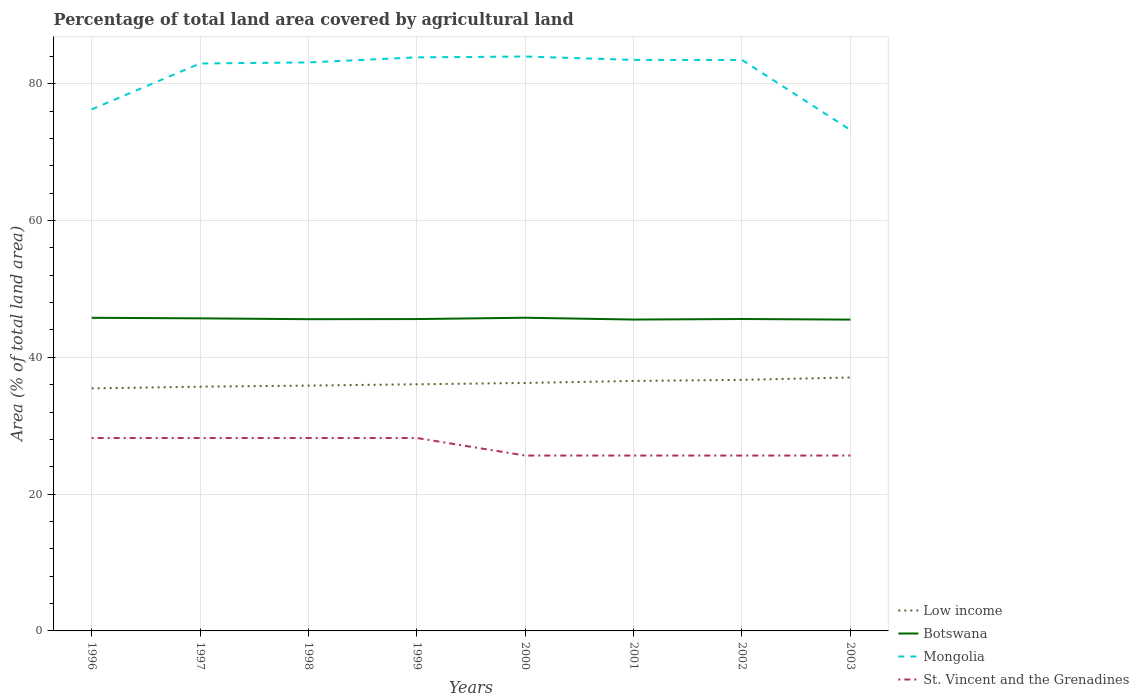How many different coloured lines are there?
Offer a terse response. 4. Does the line corresponding to St. Vincent and the Grenadines intersect with the line corresponding to Low income?
Offer a very short reply. No. Across all years, what is the maximum percentage of agricultural land in Botswana?
Your answer should be very brief. 45.52. In which year was the percentage of agricultural land in Botswana maximum?
Make the answer very short. 2003. What is the difference between the highest and the second highest percentage of agricultural land in Botswana?
Provide a short and direct response. 0.27. What is the difference between the highest and the lowest percentage of agricultural land in Botswana?
Your response must be concise. 3. How many lines are there?
Your response must be concise. 4. How many years are there in the graph?
Your answer should be very brief. 8. Where does the legend appear in the graph?
Your answer should be very brief. Bottom right. What is the title of the graph?
Provide a succinct answer. Percentage of total land area covered by agricultural land. What is the label or title of the X-axis?
Keep it short and to the point. Years. What is the label or title of the Y-axis?
Make the answer very short. Area (% of total land area). What is the Area (% of total land area) in Low income in 1996?
Provide a succinct answer. 35.46. What is the Area (% of total land area) of Botswana in 1996?
Offer a terse response. 45.78. What is the Area (% of total land area) of Mongolia in 1996?
Give a very brief answer. 76.26. What is the Area (% of total land area) in St. Vincent and the Grenadines in 1996?
Offer a terse response. 28.21. What is the Area (% of total land area) in Low income in 1997?
Keep it short and to the point. 35.71. What is the Area (% of total land area) in Botswana in 1997?
Keep it short and to the point. 45.7. What is the Area (% of total land area) of Mongolia in 1997?
Make the answer very short. 82.96. What is the Area (% of total land area) of St. Vincent and the Grenadines in 1997?
Offer a very short reply. 28.21. What is the Area (% of total land area) of Low income in 1998?
Offer a very short reply. 35.87. What is the Area (% of total land area) of Botswana in 1998?
Offer a terse response. 45.58. What is the Area (% of total land area) in Mongolia in 1998?
Make the answer very short. 83.12. What is the Area (% of total land area) in St. Vincent and the Grenadines in 1998?
Ensure brevity in your answer.  28.21. What is the Area (% of total land area) of Low income in 1999?
Your response must be concise. 36.06. What is the Area (% of total land area) of Botswana in 1999?
Offer a very short reply. 45.6. What is the Area (% of total land area) in Mongolia in 1999?
Your answer should be compact. 83.86. What is the Area (% of total land area) in St. Vincent and the Grenadines in 1999?
Your answer should be compact. 28.21. What is the Area (% of total land area) in Low income in 2000?
Make the answer very short. 36.25. What is the Area (% of total land area) of Botswana in 2000?
Keep it short and to the point. 45.79. What is the Area (% of total land area) in Mongolia in 2000?
Your answer should be compact. 83.98. What is the Area (% of total land area) in St. Vincent and the Grenadines in 2000?
Offer a terse response. 25.64. What is the Area (% of total land area) in Low income in 2001?
Ensure brevity in your answer.  36.55. What is the Area (% of total land area) in Botswana in 2001?
Your answer should be compact. 45.53. What is the Area (% of total land area) of Mongolia in 2001?
Give a very brief answer. 83.49. What is the Area (% of total land area) of St. Vincent and the Grenadines in 2001?
Offer a terse response. 25.64. What is the Area (% of total land area) in Low income in 2002?
Ensure brevity in your answer.  36.71. What is the Area (% of total land area) in Botswana in 2002?
Offer a terse response. 45.61. What is the Area (% of total land area) in Mongolia in 2002?
Make the answer very short. 83.48. What is the Area (% of total land area) of St. Vincent and the Grenadines in 2002?
Your answer should be very brief. 25.64. What is the Area (% of total land area) of Low income in 2003?
Ensure brevity in your answer.  37.05. What is the Area (% of total land area) in Botswana in 2003?
Keep it short and to the point. 45.52. What is the Area (% of total land area) in Mongolia in 2003?
Offer a very short reply. 73.25. What is the Area (% of total land area) of St. Vincent and the Grenadines in 2003?
Keep it short and to the point. 25.64. Across all years, what is the maximum Area (% of total land area) in Low income?
Provide a short and direct response. 37.05. Across all years, what is the maximum Area (% of total land area) in Botswana?
Offer a terse response. 45.79. Across all years, what is the maximum Area (% of total land area) in Mongolia?
Your response must be concise. 83.98. Across all years, what is the maximum Area (% of total land area) in St. Vincent and the Grenadines?
Give a very brief answer. 28.21. Across all years, what is the minimum Area (% of total land area) in Low income?
Your response must be concise. 35.46. Across all years, what is the minimum Area (% of total land area) of Botswana?
Make the answer very short. 45.52. Across all years, what is the minimum Area (% of total land area) in Mongolia?
Your answer should be very brief. 73.25. Across all years, what is the minimum Area (% of total land area) in St. Vincent and the Grenadines?
Offer a very short reply. 25.64. What is the total Area (% of total land area) of Low income in the graph?
Provide a succinct answer. 289.67. What is the total Area (% of total land area) in Botswana in the graph?
Your response must be concise. 365.1. What is the total Area (% of total land area) of Mongolia in the graph?
Ensure brevity in your answer.  650.4. What is the total Area (% of total land area) of St. Vincent and the Grenadines in the graph?
Offer a very short reply. 215.38. What is the difference between the Area (% of total land area) in Low income in 1996 and that in 1997?
Offer a very short reply. -0.25. What is the difference between the Area (% of total land area) of Botswana in 1996 and that in 1997?
Offer a very short reply. 0.08. What is the difference between the Area (% of total land area) in Mongolia in 1996 and that in 1997?
Ensure brevity in your answer.  -6.71. What is the difference between the Area (% of total land area) of St. Vincent and the Grenadines in 1996 and that in 1997?
Your answer should be very brief. 0. What is the difference between the Area (% of total land area) in Low income in 1996 and that in 1998?
Offer a very short reply. -0.41. What is the difference between the Area (% of total land area) in Botswana in 1996 and that in 1998?
Offer a terse response. 0.2. What is the difference between the Area (% of total land area) in Mongolia in 1996 and that in 1998?
Make the answer very short. -6.86. What is the difference between the Area (% of total land area) of Low income in 1996 and that in 1999?
Offer a terse response. -0.6. What is the difference between the Area (% of total land area) in Botswana in 1996 and that in 1999?
Offer a very short reply. 0.19. What is the difference between the Area (% of total land area) of Mongolia in 1996 and that in 1999?
Give a very brief answer. -7.6. What is the difference between the Area (% of total land area) of Low income in 1996 and that in 2000?
Your answer should be very brief. -0.79. What is the difference between the Area (% of total land area) of Botswana in 1996 and that in 2000?
Keep it short and to the point. -0.01. What is the difference between the Area (% of total land area) of Mongolia in 1996 and that in 2000?
Give a very brief answer. -7.72. What is the difference between the Area (% of total land area) in St. Vincent and the Grenadines in 1996 and that in 2000?
Offer a very short reply. 2.56. What is the difference between the Area (% of total land area) of Low income in 1996 and that in 2001?
Offer a very short reply. -1.09. What is the difference between the Area (% of total land area) in Botswana in 1996 and that in 2001?
Make the answer very short. 0.26. What is the difference between the Area (% of total land area) of Mongolia in 1996 and that in 2001?
Provide a succinct answer. -7.23. What is the difference between the Area (% of total land area) of St. Vincent and the Grenadines in 1996 and that in 2001?
Ensure brevity in your answer.  2.56. What is the difference between the Area (% of total land area) in Low income in 1996 and that in 2002?
Offer a terse response. -1.24. What is the difference between the Area (% of total land area) in Botswana in 1996 and that in 2002?
Your answer should be compact. 0.18. What is the difference between the Area (% of total land area) of Mongolia in 1996 and that in 2002?
Ensure brevity in your answer.  -7.23. What is the difference between the Area (% of total land area) of St. Vincent and the Grenadines in 1996 and that in 2002?
Your response must be concise. 2.56. What is the difference between the Area (% of total land area) of Low income in 1996 and that in 2003?
Keep it short and to the point. -1.59. What is the difference between the Area (% of total land area) in Botswana in 1996 and that in 2003?
Your answer should be compact. 0.26. What is the difference between the Area (% of total land area) of Mongolia in 1996 and that in 2003?
Your answer should be very brief. 3.01. What is the difference between the Area (% of total land area) in St. Vincent and the Grenadines in 1996 and that in 2003?
Your answer should be very brief. 2.56. What is the difference between the Area (% of total land area) of Low income in 1997 and that in 1998?
Give a very brief answer. -0.16. What is the difference between the Area (% of total land area) of Botswana in 1997 and that in 1998?
Provide a short and direct response. 0.12. What is the difference between the Area (% of total land area) of Mongolia in 1997 and that in 1998?
Offer a very short reply. -0.16. What is the difference between the Area (% of total land area) of Low income in 1997 and that in 1999?
Your response must be concise. -0.35. What is the difference between the Area (% of total land area) of Botswana in 1997 and that in 1999?
Your answer should be very brief. 0.11. What is the difference between the Area (% of total land area) in Mongolia in 1997 and that in 1999?
Offer a very short reply. -0.9. What is the difference between the Area (% of total land area) in Low income in 1997 and that in 2000?
Ensure brevity in your answer.  -0.54. What is the difference between the Area (% of total land area) of Botswana in 1997 and that in 2000?
Your answer should be compact. -0.09. What is the difference between the Area (% of total land area) of Mongolia in 1997 and that in 2000?
Provide a succinct answer. -1.02. What is the difference between the Area (% of total land area) in St. Vincent and the Grenadines in 1997 and that in 2000?
Your answer should be very brief. 2.56. What is the difference between the Area (% of total land area) of Low income in 1997 and that in 2001?
Provide a succinct answer. -0.84. What is the difference between the Area (% of total land area) in Botswana in 1997 and that in 2001?
Give a very brief answer. 0.18. What is the difference between the Area (% of total land area) in Mongolia in 1997 and that in 2001?
Your response must be concise. -0.52. What is the difference between the Area (% of total land area) of St. Vincent and the Grenadines in 1997 and that in 2001?
Your response must be concise. 2.56. What is the difference between the Area (% of total land area) of Low income in 1997 and that in 2002?
Your response must be concise. -0.99. What is the difference between the Area (% of total land area) in Botswana in 1997 and that in 2002?
Make the answer very short. 0.1. What is the difference between the Area (% of total land area) of Mongolia in 1997 and that in 2002?
Your response must be concise. -0.52. What is the difference between the Area (% of total land area) in St. Vincent and the Grenadines in 1997 and that in 2002?
Ensure brevity in your answer.  2.56. What is the difference between the Area (% of total land area) of Low income in 1997 and that in 2003?
Provide a succinct answer. -1.34. What is the difference between the Area (% of total land area) in Botswana in 1997 and that in 2003?
Give a very brief answer. 0.19. What is the difference between the Area (% of total land area) of Mongolia in 1997 and that in 2003?
Your answer should be very brief. 9.72. What is the difference between the Area (% of total land area) of St. Vincent and the Grenadines in 1997 and that in 2003?
Your response must be concise. 2.56. What is the difference between the Area (% of total land area) in Low income in 1998 and that in 1999?
Your answer should be compact. -0.19. What is the difference between the Area (% of total land area) in Botswana in 1998 and that in 1999?
Your answer should be very brief. -0.02. What is the difference between the Area (% of total land area) of Mongolia in 1998 and that in 1999?
Offer a terse response. -0.74. What is the difference between the Area (% of total land area) in Low income in 1998 and that in 2000?
Give a very brief answer. -0.39. What is the difference between the Area (% of total land area) of Botswana in 1998 and that in 2000?
Provide a short and direct response. -0.21. What is the difference between the Area (% of total land area) of Mongolia in 1998 and that in 2000?
Provide a short and direct response. -0.86. What is the difference between the Area (% of total land area) in St. Vincent and the Grenadines in 1998 and that in 2000?
Your answer should be compact. 2.56. What is the difference between the Area (% of total land area) of Low income in 1998 and that in 2001?
Keep it short and to the point. -0.68. What is the difference between the Area (% of total land area) of Botswana in 1998 and that in 2001?
Your response must be concise. 0.05. What is the difference between the Area (% of total land area) of Mongolia in 1998 and that in 2001?
Make the answer very short. -0.37. What is the difference between the Area (% of total land area) of St. Vincent and the Grenadines in 1998 and that in 2001?
Your response must be concise. 2.56. What is the difference between the Area (% of total land area) in Low income in 1998 and that in 2002?
Provide a succinct answer. -0.84. What is the difference between the Area (% of total land area) in Botswana in 1998 and that in 2002?
Make the answer very short. -0.03. What is the difference between the Area (% of total land area) of Mongolia in 1998 and that in 2002?
Give a very brief answer. -0.36. What is the difference between the Area (% of total land area) in St. Vincent and the Grenadines in 1998 and that in 2002?
Offer a very short reply. 2.56. What is the difference between the Area (% of total land area) of Low income in 1998 and that in 2003?
Offer a terse response. -1.19. What is the difference between the Area (% of total land area) in Botswana in 1998 and that in 2003?
Give a very brief answer. 0.06. What is the difference between the Area (% of total land area) of Mongolia in 1998 and that in 2003?
Keep it short and to the point. 9.87. What is the difference between the Area (% of total land area) of St. Vincent and the Grenadines in 1998 and that in 2003?
Your answer should be very brief. 2.56. What is the difference between the Area (% of total land area) of Low income in 1999 and that in 2000?
Your response must be concise. -0.19. What is the difference between the Area (% of total land area) of Botswana in 1999 and that in 2000?
Provide a short and direct response. -0.19. What is the difference between the Area (% of total land area) in Mongolia in 1999 and that in 2000?
Provide a succinct answer. -0.12. What is the difference between the Area (% of total land area) of St. Vincent and the Grenadines in 1999 and that in 2000?
Offer a very short reply. 2.56. What is the difference between the Area (% of total land area) of Low income in 1999 and that in 2001?
Your answer should be compact. -0.49. What is the difference between the Area (% of total land area) in Botswana in 1999 and that in 2001?
Your answer should be compact. 0.07. What is the difference between the Area (% of total land area) in Mongolia in 1999 and that in 2001?
Your answer should be compact. 0.37. What is the difference between the Area (% of total land area) in St. Vincent and the Grenadines in 1999 and that in 2001?
Offer a very short reply. 2.56. What is the difference between the Area (% of total land area) of Low income in 1999 and that in 2002?
Your answer should be very brief. -0.65. What is the difference between the Area (% of total land area) in Botswana in 1999 and that in 2002?
Provide a succinct answer. -0.01. What is the difference between the Area (% of total land area) in Mongolia in 1999 and that in 2002?
Provide a succinct answer. 0.38. What is the difference between the Area (% of total land area) of St. Vincent and the Grenadines in 1999 and that in 2002?
Provide a succinct answer. 2.56. What is the difference between the Area (% of total land area) of Low income in 1999 and that in 2003?
Make the answer very short. -0.99. What is the difference between the Area (% of total land area) in Botswana in 1999 and that in 2003?
Make the answer very short. 0.08. What is the difference between the Area (% of total land area) in Mongolia in 1999 and that in 2003?
Your response must be concise. 10.61. What is the difference between the Area (% of total land area) of St. Vincent and the Grenadines in 1999 and that in 2003?
Your answer should be very brief. 2.56. What is the difference between the Area (% of total land area) in Low income in 2000 and that in 2001?
Ensure brevity in your answer.  -0.29. What is the difference between the Area (% of total land area) in Botswana in 2000 and that in 2001?
Your response must be concise. 0.26. What is the difference between the Area (% of total land area) of Mongolia in 2000 and that in 2001?
Offer a terse response. 0.49. What is the difference between the Area (% of total land area) of Low income in 2000 and that in 2002?
Offer a terse response. -0.45. What is the difference between the Area (% of total land area) in Botswana in 2000 and that in 2002?
Your answer should be very brief. 0.19. What is the difference between the Area (% of total land area) in Mongolia in 2000 and that in 2002?
Provide a short and direct response. 0.5. What is the difference between the Area (% of total land area) of St. Vincent and the Grenadines in 2000 and that in 2002?
Provide a succinct answer. 0. What is the difference between the Area (% of total land area) of Low income in 2000 and that in 2003?
Make the answer very short. -0.8. What is the difference between the Area (% of total land area) of Botswana in 2000 and that in 2003?
Offer a terse response. 0.27. What is the difference between the Area (% of total land area) in Mongolia in 2000 and that in 2003?
Your answer should be very brief. 10.73. What is the difference between the Area (% of total land area) in Low income in 2001 and that in 2002?
Give a very brief answer. -0.16. What is the difference between the Area (% of total land area) in Botswana in 2001 and that in 2002?
Make the answer very short. -0.08. What is the difference between the Area (% of total land area) in Mongolia in 2001 and that in 2002?
Keep it short and to the point. 0.01. What is the difference between the Area (% of total land area) of Low income in 2001 and that in 2003?
Keep it short and to the point. -0.51. What is the difference between the Area (% of total land area) of Botswana in 2001 and that in 2003?
Give a very brief answer. 0.01. What is the difference between the Area (% of total land area) in Mongolia in 2001 and that in 2003?
Keep it short and to the point. 10.24. What is the difference between the Area (% of total land area) of St. Vincent and the Grenadines in 2001 and that in 2003?
Keep it short and to the point. 0. What is the difference between the Area (% of total land area) in Low income in 2002 and that in 2003?
Ensure brevity in your answer.  -0.35. What is the difference between the Area (% of total land area) in Botswana in 2002 and that in 2003?
Provide a short and direct response. 0.09. What is the difference between the Area (% of total land area) of Mongolia in 2002 and that in 2003?
Your response must be concise. 10.23. What is the difference between the Area (% of total land area) in St. Vincent and the Grenadines in 2002 and that in 2003?
Make the answer very short. 0. What is the difference between the Area (% of total land area) in Low income in 1996 and the Area (% of total land area) in Botswana in 1997?
Keep it short and to the point. -10.24. What is the difference between the Area (% of total land area) in Low income in 1996 and the Area (% of total land area) in Mongolia in 1997?
Provide a succinct answer. -47.5. What is the difference between the Area (% of total land area) in Low income in 1996 and the Area (% of total land area) in St. Vincent and the Grenadines in 1997?
Make the answer very short. 7.26. What is the difference between the Area (% of total land area) in Botswana in 1996 and the Area (% of total land area) in Mongolia in 1997?
Give a very brief answer. -37.18. What is the difference between the Area (% of total land area) in Botswana in 1996 and the Area (% of total land area) in St. Vincent and the Grenadines in 1997?
Provide a succinct answer. 17.58. What is the difference between the Area (% of total land area) in Mongolia in 1996 and the Area (% of total land area) in St. Vincent and the Grenadines in 1997?
Provide a succinct answer. 48.05. What is the difference between the Area (% of total land area) in Low income in 1996 and the Area (% of total land area) in Botswana in 1998?
Keep it short and to the point. -10.12. What is the difference between the Area (% of total land area) of Low income in 1996 and the Area (% of total land area) of Mongolia in 1998?
Offer a very short reply. -47.66. What is the difference between the Area (% of total land area) in Low income in 1996 and the Area (% of total land area) in St. Vincent and the Grenadines in 1998?
Your answer should be compact. 7.26. What is the difference between the Area (% of total land area) in Botswana in 1996 and the Area (% of total land area) in Mongolia in 1998?
Your response must be concise. -37.34. What is the difference between the Area (% of total land area) in Botswana in 1996 and the Area (% of total land area) in St. Vincent and the Grenadines in 1998?
Offer a very short reply. 17.58. What is the difference between the Area (% of total land area) in Mongolia in 1996 and the Area (% of total land area) in St. Vincent and the Grenadines in 1998?
Offer a very short reply. 48.05. What is the difference between the Area (% of total land area) of Low income in 1996 and the Area (% of total land area) of Botswana in 1999?
Your answer should be compact. -10.13. What is the difference between the Area (% of total land area) in Low income in 1996 and the Area (% of total land area) in Mongolia in 1999?
Make the answer very short. -48.4. What is the difference between the Area (% of total land area) in Low income in 1996 and the Area (% of total land area) in St. Vincent and the Grenadines in 1999?
Provide a succinct answer. 7.26. What is the difference between the Area (% of total land area) of Botswana in 1996 and the Area (% of total land area) of Mongolia in 1999?
Offer a very short reply. -38.08. What is the difference between the Area (% of total land area) of Botswana in 1996 and the Area (% of total land area) of St. Vincent and the Grenadines in 1999?
Your response must be concise. 17.58. What is the difference between the Area (% of total land area) in Mongolia in 1996 and the Area (% of total land area) in St. Vincent and the Grenadines in 1999?
Your response must be concise. 48.05. What is the difference between the Area (% of total land area) in Low income in 1996 and the Area (% of total land area) in Botswana in 2000?
Provide a succinct answer. -10.33. What is the difference between the Area (% of total land area) in Low income in 1996 and the Area (% of total land area) in Mongolia in 2000?
Provide a short and direct response. -48.52. What is the difference between the Area (% of total land area) in Low income in 1996 and the Area (% of total land area) in St. Vincent and the Grenadines in 2000?
Offer a very short reply. 9.82. What is the difference between the Area (% of total land area) in Botswana in 1996 and the Area (% of total land area) in Mongolia in 2000?
Make the answer very short. -38.2. What is the difference between the Area (% of total land area) of Botswana in 1996 and the Area (% of total land area) of St. Vincent and the Grenadines in 2000?
Your answer should be compact. 20.14. What is the difference between the Area (% of total land area) of Mongolia in 1996 and the Area (% of total land area) of St. Vincent and the Grenadines in 2000?
Your response must be concise. 50.62. What is the difference between the Area (% of total land area) of Low income in 1996 and the Area (% of total land area) of Botswana in 2001?
Give a very brief answer. -10.06. What is the difference between the Area (% of total land area) of Low income in 1996 and the Area (% of total land area) of Mongolia in 2001?
Offer a very short reply. -48.03. What is the difference between the Area (% of total land area) in Low income in 1996 and the Area (% of total land area) in St. Vincent and the Grenadines in 2001?
Give a very brief answer. 9.82. What is the difference between the Area (% of total land area) of Botswana in 1996 and the Area (% of total land area) of Mongolia in 2001?
Provide a short and direct response. -37.71. What is the difference between the Area (% of total land area) in Botswana in 1996 and the Area (% of total land area) in St. Vincent and the Grenadines in 2001?
Make the answer very short. 20.14. What is the difference between the Area (% of total land area) of Mongolia in 1996 and the Area (% of total land area) of St. Vincent and the Grenadines in 2001?
Provide a short and direct response. 50.62. What is the difference between the Area (% of total land area) of Low income in 1996 and the Area (% of total land area) of Botswana in 2002?
Ensure brevity in your answer.  -10.14. What is the difference between the Area (% of total land area) of Low income in 1996 and the Area (% of total land area) of Mongolia in 2002?
Ensure brevity in your answer.  -48.02. What is the difference between the Area (% of total land area) of Low income in 1996 and the Area (% of total land area) of St. Vincent and the Grenadines in 2002?
Provide a short and direct response. 9.82. What is the difference between the Area (% of total land area) in Botswana in 1996 and the Area (% of total land area) in Mongolia in 2002?
Give a very brief answer. -37.7. What is the difference between the Area (% of total land area) in Botswana in 1996 and the Area (% of total land area) in St. Vincent and the Grenadines in 2002?
Ensure brevity in your answer.  20.14. What is the difference between the Area (% of total land area) in Mongolia in 1996 and the Area (% of total land area) in St. Vincent and the Grenadines in 2002?
Offer a very short reply. 50.62. What is the difference between the Area (% of total land area) in Low income in 1996 and the Area (% of total land area) in Botswana in 2003?
Give a very brief answer. -10.06. What is the difference between the Area (% of total land area) in Low income in 1996 and the Area (% of total land area) in Mongolia in 2003?
Your response must be concise. -37.79. What is the difference between the Area (% of total land area) of Low income in 1996 and the Area (% of total land area) of St. Vincent and the Grenadines in 2003?
Make the answer very short. 9.82. What is the difference between the Area (% of total land area) of Botswana in 1996 and the Area (% of total land area) of Mongolia in 2003?
Your answer should be very brief. -27.47. What is the difference between the Area (% of total land area) of Botswana in 1996 and the Area (% of total land area) of St. Vincent and the Grenadines in 2003?
Your response must be concise. 20.14. What is the difference between the Area (% of total land area) of Mongolia in 1996 and the Area (% of total land area) of St. Vincent and the Grenadines in 2003?
Your response must be concise. 50.62. What is the difference between the Area (% of total land area) of Low income in 1997 and the Area (% of total land area) of Botswana in 1998?
Provide a succinct answer. -9.87. What is the difference between the Area (% of total land area) of Low income in 1997 and the Area (% of total land area) of Mongolia in 1998?
Your answer should be compact. -47.41. What is the difference between the Area (% of total land area) in Low income in 1997 and the Area (% of total land area) in St. Vincent and the Grenadines in 1998?
Offer a terse response. 7.51. What is the difference between the Area (% of total land area) in Botswana in 1997 and the Area (% of total land area) in Mongolia in 1998?
Ensure brevity in your answer.  -37.42. What is the difference between the Area (% of total land area) in Botswana in 1997 and the Area (% of total land area) in St. Vincent and the Grenadines in 1998?
Ensure brevity in your answer.  17.5. What is the difference between the Area (% of total land area) in Mongolia in 1997 and the Area (% of total land area) in St. Vincent and the Grenadines in 1998?
Provide a short and direct response. 54.76. What is the difference between the Area (% of total land area) of Low income in 1997 and the Area (% of total land area) of Botswana in 1999?
Provide a succinct answer. -9.89. What is the difference between the Area (% of total land area) of Low income in 1997 and the Area (% of total land area) of Mongolia in 1999?
Offer a very short reply. -48.15. What is the difference between the Area (% of total land area) of Low income in 1997 and the Area (% of total land area) of St. Vincent and the Grenadines in 1999?
Offer a very short reply. 7.51. What is the difference between the Area (% of total land area) in Botswana in 1997 and the Area (% of total land area) in Mongolia in 1999?
Your response must be concise. -38.16. What is the difference between the Area (% of total land area) of Botswana in 1997 and the Area (% of total land area) of St. Vincent and the Grenadines in 1999?
Ensure brevity in your answer.  17.5. What is the difference between the Area (% of total land area) in Mongolia in 1997 and the Area (% of total land area) in St. Vincent and the Grenadines in 1999?
Your answer should be very brief. 54.76. What is the difference between the Area (% of total land area) of Low income in 1997 and the Area (% of total land area) of Botswana in 2000?
Your response must be concise. -10.08. What is the difference between the Area (% of total land area) of Low income in 1997 and the Area (% of total land area) of Mongolia in 2000?
Your answer should be compact. -48.27. What is the difference between the Area (% of total land area) in Low income in 1997 and the Area (% of total land area) in St. Vincent and the Grenadines in 2000?
Give a very brief answer. 10.07. What is the difference between the Area (% of total land area) in Botswana in 1997 and the Area (% of total land area) in Mongolia in 2000?
Offer a very short reply. -38.28. What is the difference between the Area (% of total land area) in Botswana in 1997 and the Area (% of total land area) in St. Vincent and the Grenadines in 2000?
Your answer should be very brief. 20.06. What is the difference between the Area (% of total land area) of Mongolia in 1997 and the Area (% of total land area) of St. Vincent and the Grenadines in 2000?
Your answer should be compact. 57.32. What is the difference between the Area (% of total land area) in Low income in 1997 and the Area (% of total land area) in Botswana in 2001?
Provide a short and direct response. -9.81. What is the difference between the Area (% of total land area) in Low income in 1997 and the Area (% of total land area) in Mongolia in 2001?
Your answer should be compact. -47.78. What is the difference between the Area (% of total land area) of Low income in 1997 and the Area (% of total land area) of St. Vincent and the Grenadines in 2001?
Your answer should be very brief. 10.07. What is the difference between the Area (% of total land area) of Botswana in 1997 and the Area (% of total land area) of Mongolia in 2001?
Make the answer very short. -37.79. What is the difference between the Area (% of total land area) of Botswana in 1997 and the Area (% of total land area) of St. Vincent and the Grenadines in 2001?
Make the answer very short. 20.06. What is the difference between the Area (% of total land area) in Mongolia in 1997 and the Area (% of total land area) in St. Vincent and the Grenadines in 2001?
Offer a terse response. 57.32. What is the difference between the Area (% of total land area) of Low income in 1997 and the Area (% of total land area) of Botswana in 2002?
Offer a terse response. -9.89. What is the difference between the Area (% of total land area) in Low income in 1997 and the Area (% of total land area) in Mongolia in 2002?
Your response must be concise. -47.77. What is the difference between the Area (% of total land area) in Low income in 1997 and the Area (% of total land area) in St. Vincent and the Grenadines in 2002?
Keep it short and to the point. 10.07. What is the difference between the Area (% of total land area) in Botswana in 1997 and the Area (% of total land area) in Mongolia in 2002?
Offer a very short reply. -37.78. What is the difference between the Area (% of total land area) in Botswana in 1997 and the Area (% of total land area) in St. Vincent and the Grenadines in 2002?
Make the answer very short. 20.06. What is the difference between the Area (% of total land area) of Mongolia in 1997 and the Area (% of total land area) of St. Vincent and the Grenadines in 2002?
Your response must be concise. 57.32. What is the difference between the Area (% of total land area) of Low income in 1997 and the Area (% of total land area) of Botswana in 2003?
Offer a terse response. -9.81. What is the difference between the Area (% of total land area) in Low income in 1997 and the Area (% of total land area) in Mongolia in 2003?
Your response must be concise. -37.54. What is the difference between the Area (% of total land area) of Low income in 1997 and the Area (% of total land area) of St. Vincent and the Grenadines in 2003?
Provide a succinct answer. 10.07. What is the difference between the Area (% of total land area) in Botswana in 1997 and the Area (% of total land area) in Mongolia in 2003?
Provide a short and direct response. -27.55. What is the difference between the Area (% of total land area) of Botswana in 1997 and the Area (% of total land area) of St. Vincent and the Grenadines in 2003?
Offer a terse response. 20.06. What is the difference between the Area (% of total land area) of Mongolia in 1997 and the Area (% of total land area) of St. Vincent and the Grenadines in 2003?
Make the answer very short. 57.32. What is the difference between the Area (% of total land area) of Low income in 1998 and the Area (% of total land area) of Botswana in 1999?
Your response must be concise. -9.73. What is the difference between the Area (% of total land area) of Low income in 1998 and the Area (% of total land area) of Mongolia in 1999?
Your response must be concise. -47.99. What is the difference between the Area (% of total land area) of Low income in 1998 and the Area (% of total land area) of St. Vincent and the Grenadines in 1999?
Keep it short and to the point. 7.66. What is the difference between the Area (% of total land area) of Botswana in 1998 and the Area (% of total land area) of Mongolia in 1999?
Your response must be concise. -38.28. What is the difference between the Area (% of total land area) in Botswana in 1998 and the Area (% of total land area) in St. Vincent and the Grenadines in 1999?
Your answer should be compact. 17.37. What is the difference between the Area (% of total land area) in Mongolia in 1998 and the Area (% of total land area) in St. Vincent and the Grenadines in 1999?
Provide a short and direct response. 54.91. What is the difference between the Area (% of total land area) in Low income in 1998 and the Area (% of total land area) in Botswana in 2000?
Provide a succinct answer. -9.92. What is the difference between the Area (% of total land area) in Low income in 1998 and the Area (% of total land area) in Mongolia in 2000?
Keep it short and to the point. -48.11. What is the difference between the Area (% of total land area) of Low income in 1998 and the Area (% of total land area) of St. Vincent and the Grenadines in 2000?
Your answer should be compact. 10.23. What is the difference between the Area (% of total land area) in Botswana in 1998 and the Area (% of total land area) in Mongolia in 2000?
Provide a short and direct response. -38.4. What is the difference between the Area (% of total land area) in Botswana in 1998 and the Area (% of total land area) in St. Vincent and the Grenadines in 2000?
Your response must be concise. 19.94. What is the difference between the Area (% of total land area) in Mongolia in 1998 and the Area (% of total land area) in St. Vincent and the Grenadines in 2000?
Keep it short and to the point. 57.48. What is the difference between the Area (% of total land area) of Low income in 1998 and the Area (% of total land area) of Botswana in 2001?
Make the answer very short. -9.66. What is the difference between the Area (% of total land area) of Low income in 1998 and the Area (% of total land area) of Mongolia in 2001?
Make the answer very short. -47.62. What is the difference between the Area (% of total land area) in Low income in 1998 and the Area (% of total land area) in St. Vincent and the Grenadines in 2001?
Provide a short and direct response. 10.23. What is the difference between the Area (% of total land area) of Botswana in 1998 and the Area (% of total land area) of Mongolia in 2001?
Give a very brief answer. -37.91. What is the difference between the Area (% of total land area) in Botswana in 1998 and the Area (% of total land area) in St. Vincent and the Grenadines in 2001?
Your answer should be compact. 19.94. What is the difference between the Area (% of total land area) in Mongolia in 1998 and the Area (% of total land area) in St. Vincent and the Grenadines in 2001?
Make the answer very short. 57.48. What is the difference between the Area (% of total land area) of Low income in 1998 and the Area (% of total land area) of Botswana in 2002?
Give a very brief answer. -9.74. What is the difference between the Area (% of total land area) in Low income in 1998 and the Area (% of total land area) in Mongolia in 2002?
Ensure brevity in your answer.  -47.61. What is the difference between the Area (% of total land area) of Low income in 1998 and the Area (% of total land area) of St. Vincent and the Grenadines in 2002?
Make the answer very short. 10.23. What is the difference between the Area (% of total land area) in Botswana in 1998 and the Area (% of total land area) in Mongolia in 2002?
Offer a very short reply. -37.9. What is the difference between the Area (% of total land area) in Botswana in 1998 and the Area (% of total land area) in St. Vincent and the Grenadines in 2002?
Provide a succinct answer. 19.94. What is the difference between the Area (% of total land area) in Mongolia in 1998 and the Area (% of total land area) in St. Vincent and the Grenadines in 2002?
Give a very brief answer. 57.48. What is the difference between the Area (% of total land area) in Low income in 1998 and the Area (% of total land area) in Botswana in 2003?
Keep it short and to the point. -9.65. What is the difference between the Area (% of total land area) of Low income in 1998 and the Area (% of total land area) of Mongolia in 2003?
Your answer should be very brief. -37.38. What is the difference between the Area (% of total land area) in Low income in 1998 and the Area (% of total land area) in St. Vincent and the Grenadines in 2003?
Keep it short and to the point. 10.23. What is the difference between the Area (% of total land area) of Botswana in 1998 and the Area (% of total land area) of Mongolia in 2003?
Offer a terse response. -27.67. What is the difference between the Area (% of total land area) in Botswana in 1998 and the Area (% of total land area) in St. Vincent and the Grenadines in 2003?
Ensure brevity in your answer.  19.94. What is the difference between the Area (% of total land area) in Mongolia in 1998 and the Area (% of total land area) in St. Vincent and the Grenadines in 2003?
Your response must be concise. 57.48. What is the difference between the Area (% of total land area) of Low income in 1999 and the Area (% of total land area) of Botswana in 2000?
Offer a terse response. -9.73. What is the difference between the Area (% of total land area) of Low income in 1999 and the Area (% of total land area) of Mongolia in 2000?
Your answer should be very brief. -47.92. What is the difference between the Area (% of total land area) of Low income in 1999 and the Area (% of total land area) of St. Vincent and the Grenadines in 2000?
Keep it short and to the point. 10.42. What is the difference between the Area (% of total land area) of Botswana in 1999 and the Area (% of total land area) of Mongolia in 2000?
Provide a succinct answer. -38.38. What is the difference between the Area (% of total land area) in Botswana in 1999 and the Area (% of total land area) in St. Vincent and the Grenadines in 2000?
Give a very brief answer. 19.96. What is the difference between the Area (% of total land area) of Mongolia in 1999 and the Area (% of total land area) of St. Vincent and the Grenadines in 2000?
Offer a very short reply. 58.22. What is the difference between the Area (% of total land area) of Low income in 1999 and the Area (% of total land area) of Botswana in 2001?
Keep it short and to the point. -9.47. What is the difference between the Area (% of total land area) of Low income in 1999 and the Area (% of total land area) of Mongolia in 2001?
Give a very brief answer. -47.43. What is the difference between the Area (% of total land area) of Low income in 1999 and the Area (% of total land area) of St. Vincent and the Grenadines in 2001?
Your response must be concise. 10.42. What is the difference between the Area (% of total land area) of Botswana in 1999 and the Area (% of total land area) of Mongolia in 2001?
Give a very brief answer. -37.89. What is the difference between the Area (% of total land area) in Botswana in 1999 and the Area (% of total land area) in St. Vincent and the Grenadines in 2001?
Give a very brief answer. 19.96. What is the difference between the Area (% of total land area) of Mongolia in 1999 and the Area (% of total land area) of St. Vincent and the Grenadines in 2001?
Your response must be concise. 58.22. What is the difference between the Area (% of total land area) in Low income in 1999 and the Area (% of total land area) in Botswana in 2002?
Offer a very short reply. -9.54. What is the difference between the Area (% of total land area) of Low income in 1999 and the Area (% of total land area) of Mongolia in 2002?
Offer a terse response. -47.42. What is the difference between the Area (% of total land area) in Low income in 1999 and the Area (% of total land area) in St. Vincent and the Grenadines in 2002?
Give a very brief answer. 10.42. What is the difference between the Area (% of total land area) in Botswana in 1999 and the Area (% of total land area) in Mongolia in 2002?
Make the answer very short. -37.89. What is the difference between the Area (% of total land area) in Botswana in 1999 and the Area (% of total land area) in St. Vincent and the Grenadines in 2002?
Ensure brevity in your answer.  19.96. What is the difference between the Area (% of total land area) in Mongolia in 1999 and the Area (% of total land area) in St. Vincent and the Grenadines in 2002?
Your response must be concise. 58.22. What is the difference between the Area (% of total land area) of Low income in 1999 and the Area (% of total land area) of Botswana in 2003?
Your answer should be very brief. -9.46. What is the difference between the Area (% of total land area) of Low income in 1999 and the Area (% of total land area) of Mongolia in 2003?
Provide a short and direct response. -37.19. What is the difference between the Area (% of total land area) in Low income in 1999 and the Area (% of total land area) in St. Vincent and the Grenadines in 2003?
Ensure brevity in your answer.  10.42. What is the difference between the Area (% of total land area) in Botswana in 1999 and the Area (% of total land area) in Mongolia in 2003?
Provide a succinct answer. -27.65. What is the difference between the Area (% of total land area) in Botswana in 1999 and the Area (% of total land area) in St. Vincent and the Grenadines in 2003?
Your answer should be very brief. 19.96. What is the difference between the Area (% of total land area) in Mongolia in 1999 and the Area (% of total land area) in St. Vincent and the Grenadines in 2003?
Provide a succinct answer. 58.22. What is the difference between the Area (% of total land area) of Low income in 2000 and the Area (% of total land area) of Botswana in 2001?
Make the answer very short. -9.27. What is the difference between the Area (% of total land area) of Low income in 2000 and the Area (% of total land area) of Mongolia in 2001?
Offer a very short reply. -47.23. What is the difference between the Area (% of total land area) of Low income in 2000 and the Area (% of total land area) of St. Vincent and the Grenadines in 2001?
Offer a terse response. 10.61. What is the difference between the Area (% of total land area) of Botswana in 2000 and the Area (% of total land area) of Mongolia in 2001?
Offer a terse response. -37.7. What is the difference between the Area (% of total land area) of Botswana in 2000 and the Area (% of total land area) of St. Vincent and the Grenadines in 2001?
Ensure brevity in your answer.  20.15. What is the difference between the Area (% of total land area) in Mongolia in 2000 and the Area (% of total land area) in St. Vincent and the Grenadines in 2001?
Offer a very short reply. 58.34. What is the difference between the Area (% of total land area) of Low income in 2000 and the Area (% of total land area) of Botswana in 2002?
Keep it short and to the point. -9.35. What is the difference between the Area (% of total land area) in Low income in 2000 and the Area (% of total land area) in Mongolia in 2002?
Keep it short and to the point. -47.23. What is the difference between the Area (% of total land area) in Low income in 2000 and the Area (% of total land area) in St. Vincent and the Grenadines in 2002?
Keep it short and to the point. 10.61. What is the difference between the Area (% of total land area) of Botswana in 2000 and the Area (% of total land area) of Mongolia in 2002?
Offer a very short reply. -37.69. What is the difference between the Area (% of total land area) of Botswana in 2000 and the Area (% of total land area) of St. Vincent and the Grenadines in 2002?
Make the answer very short. 20.15. What is the difference between the Area (% of total land area) of Mongolia in 2000 and the Area (% of total land area) of St. Vincent and the Grenadines in 2002?
Offer a terse response. 58.34. What is the difference between the Area (% of total land area) of Low income in 2000 and the Area (% of total land area) of Botswana in 2003?
Give a very brief answer. -9.26. What is the difference between the Area (% of total land area) of Low income in 2000 and the Area (% of total land area) of Mongolia in 2003?
Ensure brevity in your answer.  -36.99. What is the difference between the Area (% of total land area) in Low income in 2000 and the Area (% of total land area) in St. Vincent and the Grenadines in 2003?
Offer a very short reply. 10.61. What is the difference between the Area (% of total land area) in Botswana in 2000 and the Area (% of total land area) in Mongolia in 2003?
Offer a terse response. -27.46. What is the difference between the Area (% of total land area) in Botswana in 2000 and the Area (% of total land area) in St. Vincent and the Grenadines in 2003?
Your answer should be very brief. 20.15. What is the difference between the Area (% of total land area) of Mongolia in 2000 and the Area (% of total land area) of St. Vincent and the Grenadines in 2003?
Keep it short and to the point. 58.34. What is the difference between the Area (% of total land area) of Low income in 2001 and the Area (% of total land area) of Botswana in 2002?
Provide a succinct answer. -9.06. What is the difference between the Area (% of total land area) of Low income in 2001 and the Area (% of total land area) of Mongolia in 2002?
Ensure brevity in your answer.  -46.93. What is the difference between the Area (% of total land area) in Low income in 2001 and the Area (% of total land area) in St. Vincent and the Grenadines in 2002?
Provide a succinct answer. 10.91. What is the difference between the Area (% of total land area) in Botswana in 2001 and the Area (% of total land area) in Mongolia in 2002?
Offer a terse response. -37.96. What is the difference between the Area (% of total land area) of Botswana in 2001 and the Area (% of total land area) of St. Vincent and the Grenadines in 2002?
Offer a terse response. 19.89. What is the difference between the Area (% of total land area) of Mongolia in 2001 and the Area (% of total land area) of St. Vincent and the Grenadines in 2002?
Provide a succinct answer. 57.85. What is the difference between the Area (% of total land area) in Low income in 2001 and the Area (% of total land area) in Botswana in 2003?
Give a very brief answer. -8.97. What is the difference between the Area (% of total land area) of Low income in 2001 and the Area (% of total land area) of Mongolia in 2003?
Ensure brevity in your answer.  -36.7. What is the difference between the Area (% of total land area) in Low income in 2001 and the Area (% of total land area) in St. Vincent and the Grenadines in 2003?
Your answer should be very brief. 10.91. What is the difference between the Area (% of total land area) of Botswana in 2001 and the Area (% of total land area) of Mongolia in 2003?
Provide a succinct answer. -27.72. What is the difference between the Area (% of total land area) of Botswana in 2001 and the Area (% of total land area) of St. Vincent and the Grenadines in 2003?
Your answer should be compact. 19.89. What is the difference between the Area (% of total land area) in Mongolia in 2001 and the Area (% of total land area) in St. Vincent and the Grenadines in 2003?
Offer a terse response. 57.85. What is the difference between the Area (% of total land area) in Low income in 2002 and the Area (% of total land area) in Botswana in 2003?
Offer a very short reply. -8.81. What is the difference between the Area (% of total land area) of Low income in 2002 and the Area (% of total land area) of Mongolia in 2003?
Keep it short and to the point. -36.54. What is the difference between the Area (% of total land area) in Low income in 2002 and the Area (% of total land area) in St. Vincent and the Grenadines in 2003?
Give a very brief answer. 11.06. What is the difference between the Area (% of total land area) of Botswana in 2002 and the Area (% of total land area) of Mongolia in 2003?
Give a very brief answer. -27.64. What is the difference between the Area (% of total land area) in Botswana in 2002 and the Area (% of total land area) in St. Vincent and the Grenadines in 2003?
Your answer should be very brief. 19.96. What is the difference between the Area (% of total land area) of Mongolia in 2002 and the Area (% of total land area) of St. Vincent and the Grenadines in 2003?
Provide a short and direct response. 57.84. What is the average Area (% of total land area) in Low income per year?
Provide a short and direct response. 36.21. What is the average Area (% of total land area) in Botswana per year?
Offer a very short reply. 45.64. What is the average Area (% of total land area) of Mongolia per year?
Provide a succinct answer. 81.3. What is the average Area (% of total land area) in St. Vincent and the Grenadines per year?
Your answer should be very brief. 26.92. In the year 1996, what is the difference between the Area (% of total land area) in Low income and Area (% of total land area) in Botswana?
Ensure brevity in your answer.  -10.32. In the year 1996, what is the difference between the Area (% of total land area) in Low income and Area (% of total land area) in Mongolia?
Give a very brief answer. -40.79. In the year 1996, what is the difference between the Area (% of total land area) in Low income and Area (% of total land area) in St. Vincent and the Grenadines?
Provide a succinct answer. 7.26. In the year 1996, what is the difference between the Area (% of total land area) in Botswana and Area (% of total land area) in Mongolia?
Give a very brief answer. -30.47. In the year 1996, what is the difference between the Area (% of total land area) in Botswana and Area (% of total land area) in St. Vincent and the Grenadines?
Give a very brief answer. 17.58. In the year 1996, what is the difference between the Area (% of total land area) in Mongolia and Area (% of total land area) in St. Vincent and the Grenadines?
Give a very brief answer. 48.05. In the year 1997, what is the difference between the Area (% of total land area) in Low income and Area (% of total land area) in Botswana?
Offer a terse response. -9.99. In the year 1997, what is the difference between the Area (% of total land area) in Low income and Area (% of total land area) in Mongolia?
Make the answer very short. -47.25. In the year 1997, what is the difference between the Area (% of total land area) of Low income and Area (% of total land area) of St. Vincent and the Grenadines?
Your answer should be very brief. 7.51. In the year 1997, what is the difference between the Area (% of total land area) of Botswana and Area (% of total land area) of Mongolia?
Make the answer very short. -37.26. In the year 1997, what is the difference between the Area (% of total land area) in Botswana and Area (% of total land area) in St. Vincent and the Grenadines?
Ensure brevity in your answer.  17.5. In the year 1997, what is the difference between the Area (% of total land area) of Mongolia and Area (% of total land area) of St. Vincent and the Grenadines?
Keep it short and to the point. 54.76. In the year 1998, what is the difference between the Area (% of total land area) in Low income and Area (% of total land area) in Botswana?
Keep it short and to the point. -9.71. In the year 1998, what is the difference between the Area (% of total land area) of Low income and Area (% of total land area) of Mongolia?
Offer a terse response. -47.25. In the year 1998, what is the difference between the Area (% of total land area) in Low income and Area (% of total land area) in St. Vincent and the Grenadines?
Keep it short and to the point. 7.66. In the year 1998, what is the difference between the Area (% of total land area) of Botswana and Area (% of total land area) of Mongolia?
Make the answer very short. -37.54. In the year 1998, what is the difference between the Area (% of total land area) in Botswana and Area (% of total land area) in St. Vincent and the Grenadines?
Offer a very short reply. 17.37. In the year 1998, what is the difference between the Area (% of total land area) of Mongolia and Area (% of total land area) of St. Vincent and the Grenadines?
Ensure brevity in your answer.  54.91. In the year 1999, what is the difference between the Area (% of total land area) in Low income and Area (% of total land area) in Botswana?
Provide a succinct answer. -9.54. In the year 1999, what is the difference between the Area (% of total land area) of Low income and Area (% of total land area) of Mongolia?
Your response must be concise. -47.8. In the year 1999, what is the difference between the Area (% of total land area) in Low income and Area (% of total land area) in St. Vincent and the Grenadines?
Your answer should be very brief. 7.86. In the year 1999, what is the difference between the Area (% of total land area) of Botswana and Area (% of total land area) of Mongolia?
Your response must be concise. -38.26. In the year 1999, what is the difference between the Area (% of total land area) in Botswana and Area (% of total land area) in St. Vincent and the Grenadines?
Provide a short and direct response. 17.39. In the year 1999, what is the difference between the Area (% of total land area) of Mongolia and Area (% of total land area) of St. Vincent and the Grenadines?
Your answer should be very brief. 55.66. In the year 2000, what is the difference between the Area (% of total land area) of Low income and Area (% of total land area) of Botswana?
Offer a very short reply. -9.54. In the year 2000, what is the difference between the Area (% of total land area) in Low income and Area (% of total land area) in Mongolia?
Your answer should be compact. -47.73. In the year 2000, what is the difference between the Area (% of total land area) in Low income and Area (% of total land area) in St. Vincent and the Grenadines?
Give a very brief answer. 10.61. In the year 2000, what is the difference between the Area (% of total land area) in Botswana and Area (% of total land area) in Mongolia?
Your answer should be very brief. -38.19. In the year 2000, what is the difference between the Area (% of total land area) of Botswana and Area (% of total land area) of St. Vincent and the Grenadines?
Give a very brief answer. 20.15. In the year 2000, what is the difference between the Area (% of total land area) in Mongolia and Area (% of total land area) in St. Vincent and the Grenadines?
Keep it short and to the point. 58.34. In the year 2001, what is the difference between the Area (% of total land area) in Low income and Area (% of total land area) in Botswana?
Give a very brief answer. -8.98. In the year 2001, what is the difference between the Area (% of total land area) of Low income and Area (% of total land area) of Mongolia?
Offer a terse response. -46.94. In the year 2001, what is the difference between the Area (% of total land area) of Low income and Area (% of total land area) of St. Vincent and the Grenadines?
Make the answer very short. 10.91. In the year 2001, what is the difference between the Area (% of total land area) in Botswana and Area (% of total land area) in Mongolia?
Offer a very short reply. -37.96. In the year 2001, what is the difference between the Area (% of total land area) of Botswana and Area (% of total land area) of St. Vincent and the Grenadines?
Make the answer very short. 19.89. In the year 2001, what is the difference between the Area (% of total land area) of Mongolia and Area (% of total land area) of St. Vincent and the Grenadines?
Give a very brief answer. 57.85. In the year 2002, what is the difference between the Area (% of total land area) in Low income and Area (% of total land area) in Botswana?
Offer a terse response. -8.9. In the year 2002, what is the difference between the Area (% of total land area) in Low income and Area (% of total land area) in Mongolia?
Your answer should be compact. -46.78. In the year 2002, what is the difference between the Area (% of total land area) of Low income and Area (% of total land area) of St. Vincent and the Grenadines?
Keep it short and to the point. 11.06. In the year 2002, what is the difference between the Area (% of total land area) in Botswana and Area (% of total land area) in Mongolia?
Your answer should be compact. -37.88. In the year 2002, what is the difference between the Area (% of total land area) in Botswana and Area (% of total land area) in St. Vincent and the Grenadines?
Provide a succinct answer. 19.96. In the year 2002, what is the difference between the Area (% of total land area) in Mongolia and Area (% of total land area) in St. Vincent and the Grenadines?
Ensure brevity in your answer.  57.84. In the year 2003, what is the difference between the Area (% of total land area) in Low income and Area (% of total land area) in Botswana?
Provide a succinct answer. -8.46. In the year 2003, what is the difference between the Area (% of total land area) of Low income and Area (% of total land area) of Mongolia?
Keep it short and to the point. -36.19. In the year 2003, what is the difference between the Area (% of total land area) of Low income and Area (% of total land area) of St. Vincent and the Grenadines?
Provide a short and direct response. 11.41. In the year 2003, what is the difference between the Area (% of total land area) of Botswana and Area (% of total land area) of Mongolia?
Make the answer very short. -27.73. In the year 2003, what is the difference between the Area (% of total land area) in Botswana and Area (% of total land area) in St. Vincent and the Grenadines?
Provide a short and direct response. 19.88. In the year 2003, what is the difference between the Area (% of total land area) of Mongolia and Area (% of total land area) of St. Vincent and the Grenadines?
Your answer should be very brief. 47.61. What is the ratio of the Area (% of total land area) of Low income in 1996 to that in 1997?
Offer a very short reply. 0.99. What is the ratio of the Area (% of total land area) in Mongolia in 1996 to that in 1997?
Make the answer very short. 0.92. What is the ratio of the Area (% of total land area) in Low income in 1996 to that in 1998?
Keep it short and to the point. 0.99. What is the ratio of the Area (% of total land area) of Botswana in 1996 to that in 1998?
Offer a terse response. 1. What is the ratio of the Area (% of total land area) of Mongolia in 1996 to that in 1998?
Provide a succinct answer. 0.92. What is the ratio of the Area (% of total land area) in Low income in 1996 to that in 1999?
Keep it short and to the point. 0.98. What is the ratio of the Area (% of total land area) in Mongolia in 1996 to that in 1999?
Ensure brevity in your answer.  0.91. What is the ratio of the Area (% of total land area) of St. Vincent and the Grenadines in 1996 to that in 1999?
Ensure brevity in your answer.  1. What is the ratio of the Area (% of total land area) of Low income in 1996 to that in 2000?
Keep it short and to the point. 0.98. What is the ratio of the Area (% of total land area) in Mongolia in 1996 to that in 2000?
Offer a terse response. 0.91. What is the ratio of the Area (% of total land area) in St. Vincent and the Grenadines in 1996 to that in 2000?
Make the answer very short. 1.1. What is the ratio of the Area (% of total land area) in Low income in 1996 to that in 2001?
Offer a terse response. 0.97. What is the ratio of the Area (% of total land area) of Botswana in 1996 to that in 2001?
Ensure brevity in your answer.  1.01. What is the ratio of the Area (% of total land area) of Mongolia in 1996 to that in 2001?
Your response must be concise. 0.91. What is the ratio of the Area (% of total land area) of Low income in 1996 to that in 2002?
Offer a very short reply. 0.97. What is the ratio of the Area (% of total land area) in Botswana in 1996 to that in 2002?
Your answer should be very brief. 1. What is the ratio of the Area (% of total land area) of Mongolia in 1996 to that in 2002?
Provide a short and direct response. 0.91. What is the ratio of the Area (% of total land area) of Botswana in 1996 to that in 2003?
Provide a short and direct response. 1.01. What is the ratio of the Area (% of total land area) of Mongolia in 1996 to that in 2003?
Offer a very short reply. 1.04. What is the ratio of the Area (% of total land area) in Low income in 1997 to that in 1998?
Ensure brevity in your answer.  1. What is the ratio of the Area (% of total land area) in Mongolia in 1997 to that in 1998?
Offer a terse response. 1. What is the ratio of the Area (% of total land area) of Low income in 1997 to that in 1999?
Keep it short and to the point. 0.99. What is the ratio of the Area (% of total land area) of Botswana in 1997 to that in 1999?
Offer a very short reply. 1. What is the ratio of the Area (% of total land area) in Mongolia in 1997 to that in 1999?
Give a very brief answer. 0.99. What is the ratio of the Area (% of total land area) in St. Vincent and the Grenadines in 1997 to that in 1999?
Your answer should be very brief. 1. What is the ratio of the Area (% of total land area) in Low income in 1997 to that in 2000?
Provide a succinct answer. 0.98. What is the ratio of the Area (% of total land area) in Mongolia in 1997 to that in 2000?
Provide a succinct answer. 0.99. What is the ratio of the Area (% of total land area) of Low income in 1997 to that in 2001?
Ensure brevity in your answer.  0.98. What is the ratio of the Area (% of total land area) of Botswana in 1997 to that in 2001?
Offer a very short reply. 1. What is the ratio of the Area (% of total land area) of Low income in 1997 to that in 2002?
Your answer should be compact. 0.97. What is the ratio of the Area (% of total land area) in Mongolia in 1997 to that in 2002?
Your response must be concise. 0.99. What is the ratio of the Area (% of total land area) in St. Vincent and the Grenadines in 1997 to that in 2002?
Your answer should be very brief. 1.1. What is the ratio of the Area (% of total land area) in Low income in 1997 to that in 2003?
Give a very brief answer. 0.96. What is the ratio of the Area (% of total land area) of Botswana in 1997 to that in 2003?
Offer a very short reply. 1. What is the ratio of the Area (% of total land area) in Mongolia in 1997 to that in 2003?
Offer a very short reply. 1.13. What is the ratio of the Area (% of total land area) in St. Vincent and the Grenadines in 1997 to that in 2003?
Keep it short and to the point. 1.1. What is the ratio of the Area (% of total land area) of Low income in 1998 to that in 1999?
Make the answer very short. 0.99. What is the ratio of the Area (% of total land area) in Botswana in 1998 to that in 1999?
Keep it short and to the point. 1. What is the ratio of the Area (% of total land area) of Low income in 1998 to that in 2000?
Make the answer very short. 0.99. What is the ratio of the Area (% of total land area) of Mongolia in 1998 to that in 2000?
Ensure brevity in your answer.  0.99. What is the ratio of the Area (% of total land area) in St. Vincent and the Grenadines in 1998 to that in 2000?
Offer a very short reply. 1.1. What is the ratio of the Area (% of total land area) in Low income in 1998 to that in 2001?
Your answer should be compact. 0.98. What is the ratio of the Area (% of total land area) of Mongolia in 1998 to that in 2001?
Offer a very short reply. 1. What is the ratio of the Area (% of total land area) in Low income in 1998 to that in 2002?
Make the answer very short. 0.98. What is the ratio of the Area (% of total land area) in Mongolia in 1998 to that in 2002?
Make the answer very short. 1. What is the ratio of the Area (% of total land area) in St. Vincent and the Grenadines in 1998 to that in 2002?
Your response must be concise. 1.1. What is the ratio of the Area (% of total land area) in Low income in 1998 to that in 2003?
Ensure brevity in your answer.  0.97. What is the ratio of the Area (% of total land area) of Botswana in 1998 to that in 2003?
Offer a terse response. 1. What is the ratio of the Area (% of total land area) of Mongolia in 1998 to that in 2003?
Keep it short and to the point. 1.13. What is the ratio of the Area (% of total land area) in Low income in 1999 to that in 2000?
Give a very brief answer. 0.99. What is the ratio of the Area (% of total land area) in Low income in 1999 to that in 2001?
Offer a terse response. 0.99. What is the ratio of the Area (% of total land area) of Botswana in 1999 to that in 2001?
Provide a short and direct response. 1. What is the ratio of the Area (% of total land area) in Low income in 1999 to that in 2002?
Offer a terse response. 0.98. What is the ratio of the Area (% of total land area) of Botswana in 1999 to that in 2002?
Ensure brevity in your answer.  1. What is the ratio of the Area (% of total land area) in Low income in 1999 to that in 2003?
Offer a very short reply. 0.97. What is the ratio of the Area (% of total land area) of Botswana in 1999 to that in 2003?
Offer a terse response. 1. What is the ratio of the Area (% of total land area) in Mongolia in 1999 to that in 2003?
Ensure brevity in your answer.  1.14. What is the ratio of the Area (% of total land area) in Low income in 2000 to that in 2001?
Offer a terse response. 0.99. What is the ratio of the Area (% of total land area) in Mongolia in 2000 to that in 2001?
Keep it short and to the point. 1.01. What is the ratio of the Area (% of total land area) of St. Vincent and the Grenadines in 2000 to that in 2001?
Your answer should be very brief. 1. What is the ratio of the Area (% of total land area) of Low income in 2000 to that in 2002?
Provide a succinct answer. 0.99. What is the ratio of the Area (% of total land area) of Mongolia in 2000 to that in 2002?
Ensure brevity in your answer.  1.01. What is the ratio of the Area (% of total land area) of St. Vincent and the Grenadines in 2000 to that in 2002?
Your answer should be compact. 1. What is the ratio of the Area (% of total land area) of Low income in 2000 to that in 2003?
Provide a short and direct response. 0.98. What is the ratio of the Area (% of total land area) of Mongolia in 2000 to that in 2003?
Provide a short and direct response. 1.15. What is the ratio of the Area (% of total land area) of St. Vincent and the Grenadines in 2000 to that in 2003?
Keep it short and to the point. 1. What is the ratio of the Area (% of total land area) in St. Vincent and the Grenadines in 2001 to that in 2002?
Give a very brief answer. 1. What is the ratio of the Area (% of total land area) of Low income in 2001 to that in 2003?
Provide a succinct answer. 0.99. What is the ratio of the Area (% of total land area) in Botswana in 2001 to that in 2003?
Give a very brief answer. 1. What is the ratio of the Area (% of total land area) in Mongolia in 2001 to that in 2003?
Offer a terse response. 1.14. What is the ratio of the Area (% of total land area) of Low income in 2002 to that in 2003?
Ensure brevity in your answer.  0.99. What is the ratio of the Area (% of total land area) in Botswana in 2002 to that in 2003?
Ensure brevity in your answer.  1. What is the ratio of the Area (% of total land area) in Mongolia in 2002 to that in 2003?
Provide a succinct answer. 1.14. What is the difference between the highest and the second highest Area (% of total land area) of Low income?
Give a very brief answer. 0.35. What is the difference between the highest and the second highest Area (% of total land area) in Botswana?
Provide a short and direct response. 0.01. What is the difference between the highest and the second highest Area (% of total land area) in Mongolia?
Provide a succinct answer. 0.12. What is the difference between the highest and the lowest Area (% of total land area) of Low income?
Your answer should be compact. 1.59. What is the difference between the highest and the lowest Area (% of total land area) of Botswana?
Provide a succinct answer. 0.27. What is the difference between the highest and the lowest Area (% of total land area) in Mongolia?
Offer a terse response. 10.73. What is the difference between the highest and the lowest Area (% of total land area) in St. Vincent and the Grenadines?
Give a very brief answer. 2.56. 